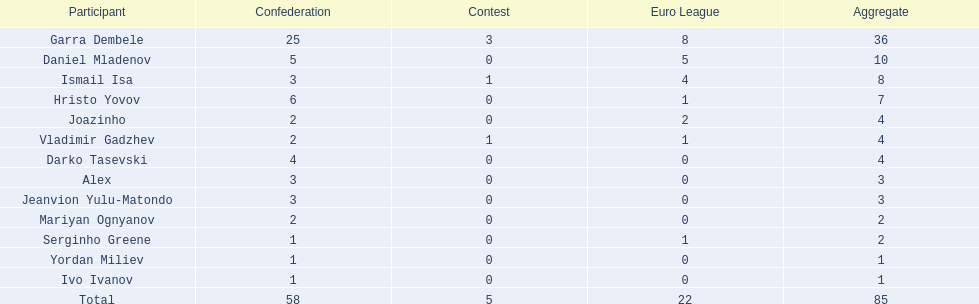What league is 2? 2, 2, 2. Which cup is less than 1? 0, 0. Which total is 2? 2. Who is the player? Mariyan Ognyanov. 